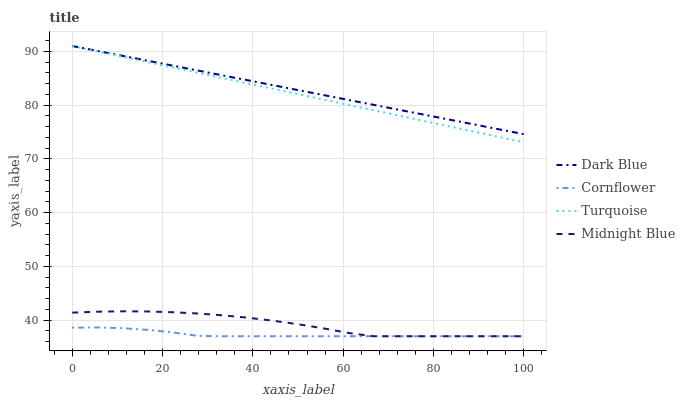Does Cornflower have the minimum area under the curve?
Answer yes or no. Yes. Does Dark Blue have the maximum area under the curve?
Answer yes or no. Yes. Does Turquoise have the minimum area under the curve?
Answer yes or no. No. Does Turquoise have the maximum area under the curve?
Answer yes or no. No. Is Turquoise the smoothest?
Answer yes or no. Yes. Is Midnight Blue the roughest?
Answer yes or no. Yes. Is Midnight Blue the smoothest?
Answer yes or no. No. Is Turquoise the roughest?
Answer yes or no. No. Does Midnight Blue have the lowest value?
Answer yes or no. Yes. Does Turquoise have the lowest value?
Answer yes or no. No. Does Turquoise have the highest value?
Answer yes or no. Yes. Does Midnight Blue have the highest value?
Answer yes or no. No. Is Midnight Blue less than Turquoise?
Answer yes or no. Yes. Is Turquoise greater than Cornflower?
Answer yes or no. Yes. Does Dark Blue intersect Turquoise?
Answer yes or no. Yes. Is Dark Blue less than Turquoise?
Answer yes or no. No. Is Dark Blue greater than Turquoise?
Answer yes or no. No. Does Midnight Blue intersect Turquoise?
Answer yes or no. No. 